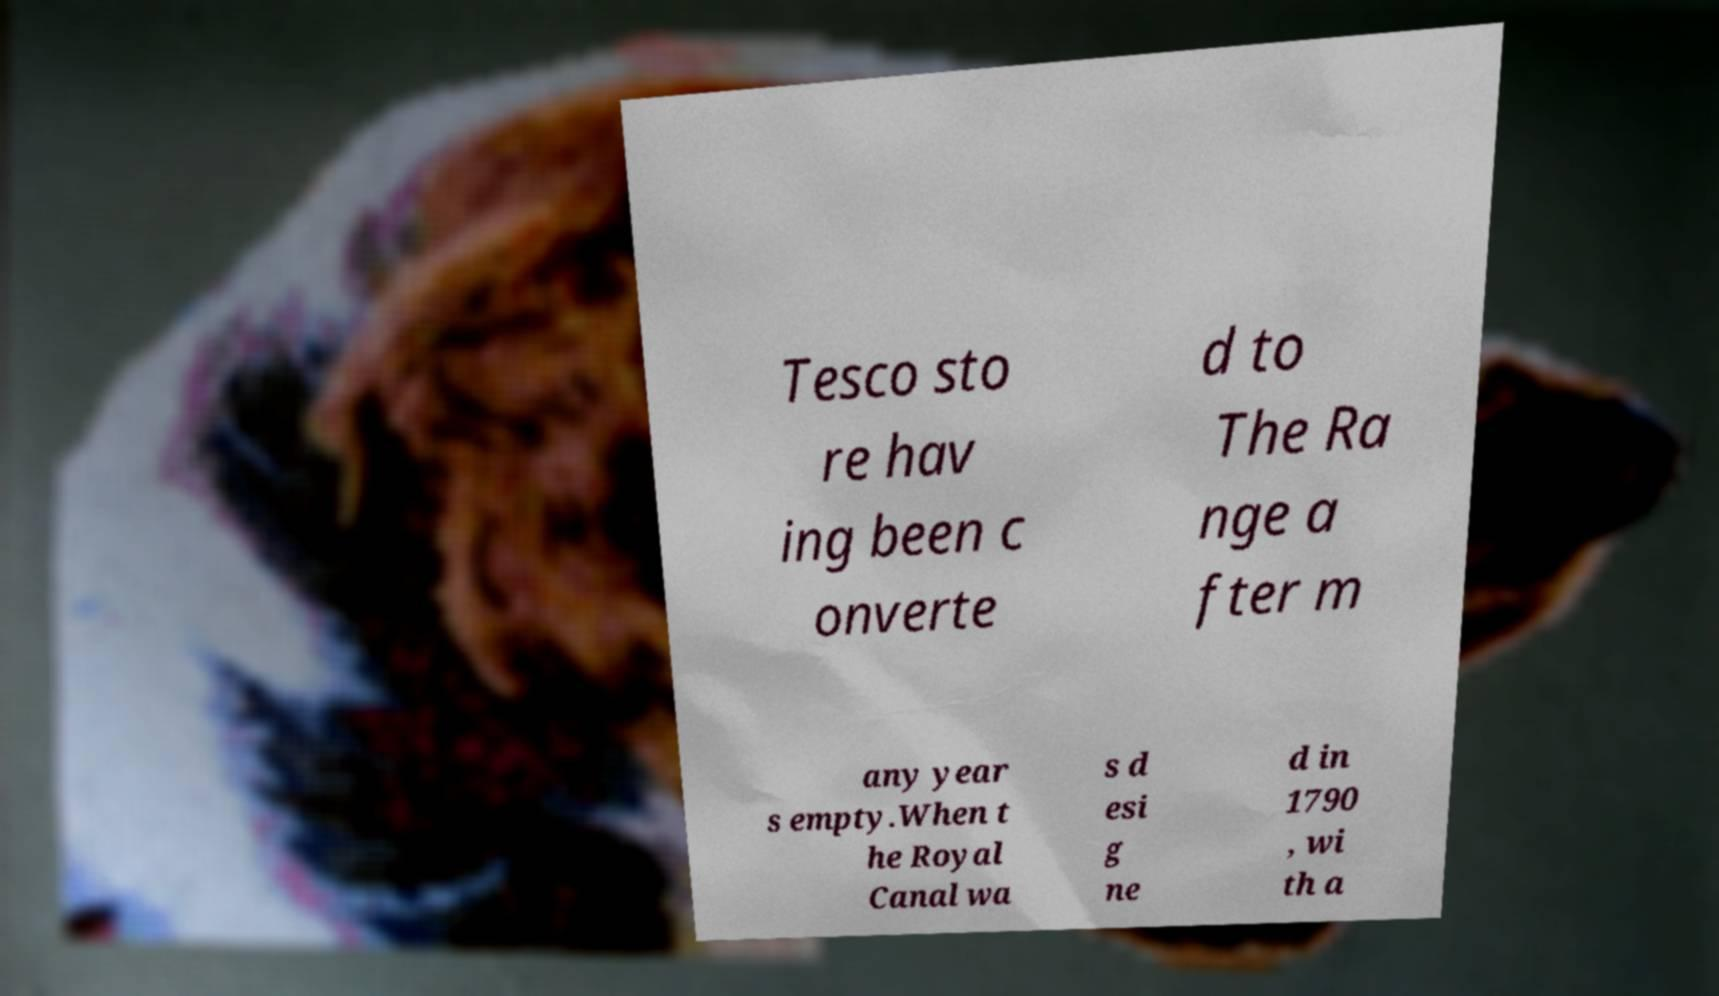Please identify and transcribe the text found in this image. Tesco sto re hav ing been c onverte d to The Ra nge a fter m any year s empty.When t he Royal Canal wa s d esi g ne d in 1790 , wi th a 